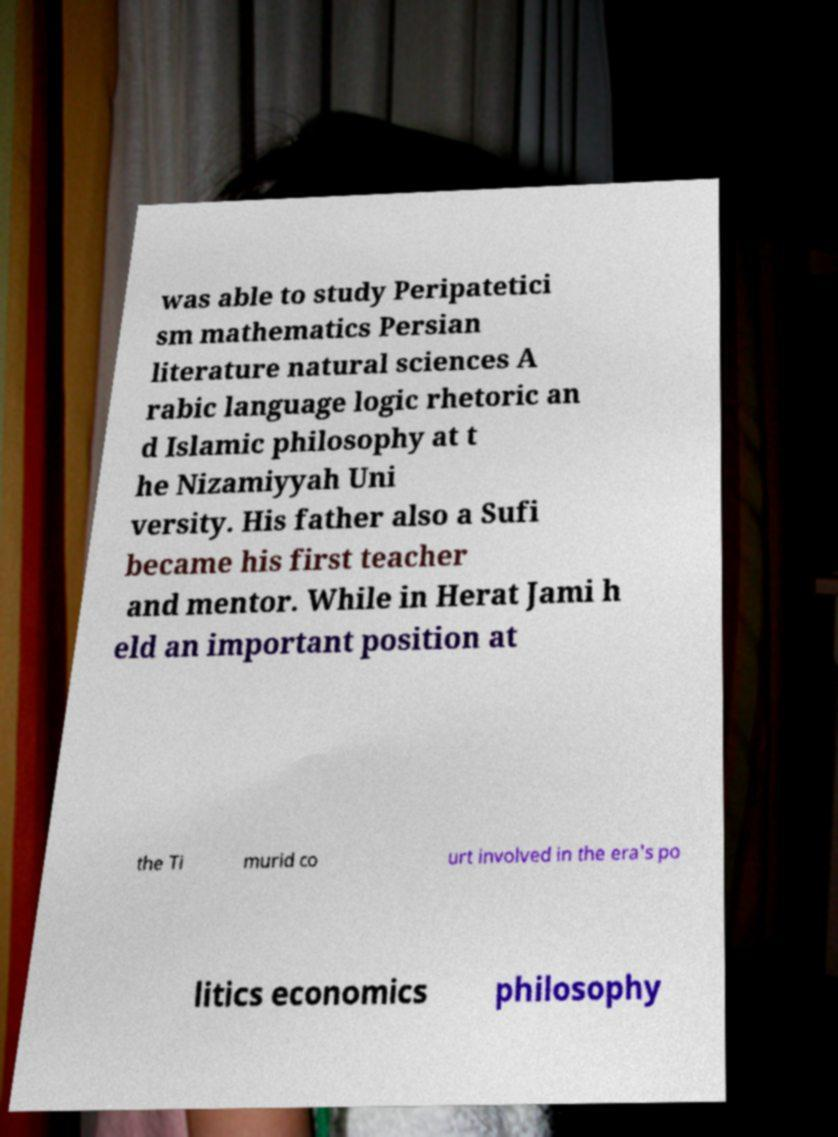Please identify and transcribe the text found in this image. was able to study Peripatetici sm mathematics Persian literature natural sciences A rabic language logic rhetoric an d Islamic philosophy at t he Nizamiyyah Uni versity. His father also a Sufi became his first teacher and mentor. While in Herat Jami h eld an important position at the Ti murid co urt involved in the era's po litics economics philosophy 